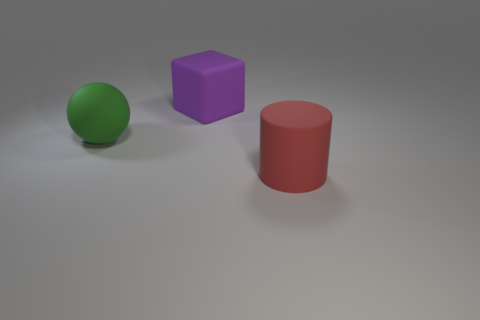What is the material of the big thing that is to the right of the large cube?
Provide a short and direct response. Rubber. Are there an equal number of big red rubber things that are right of the large purple rubber cube and green matte things?
Give a very brief answer. Yes. There is a big thing that is in front of the matte thing that is on the left side of the block; is there a sphere that is behind it?
Your response must be concise. Yes. How many red rubber things are behind the large matte object that is behind the big green rubber sphere?
Provide a succinct answer. 0. What is the color of the large rubber thing in front of the matte thing left of the big purple block?
Ensure brevity in your answer.  Red. What number of other objects are there of the same material as the big green object?
Give a very brief answer. 2. Are there any big purple shiny objects?
Make the answer very short. No. Are there more matte blocks on the right side of the large green matte ball than rubber cylinders that are to the right of the big red rubber cylinder?
Make the answer very short. Yes. How many cylinders are either big green matte things or purple objects?
Provide a short and direct response. 0. Is the shape of the big thing that is in front of the large green rubber thing the same as  the large green rubber thing?
Give a very brief answer. No. 